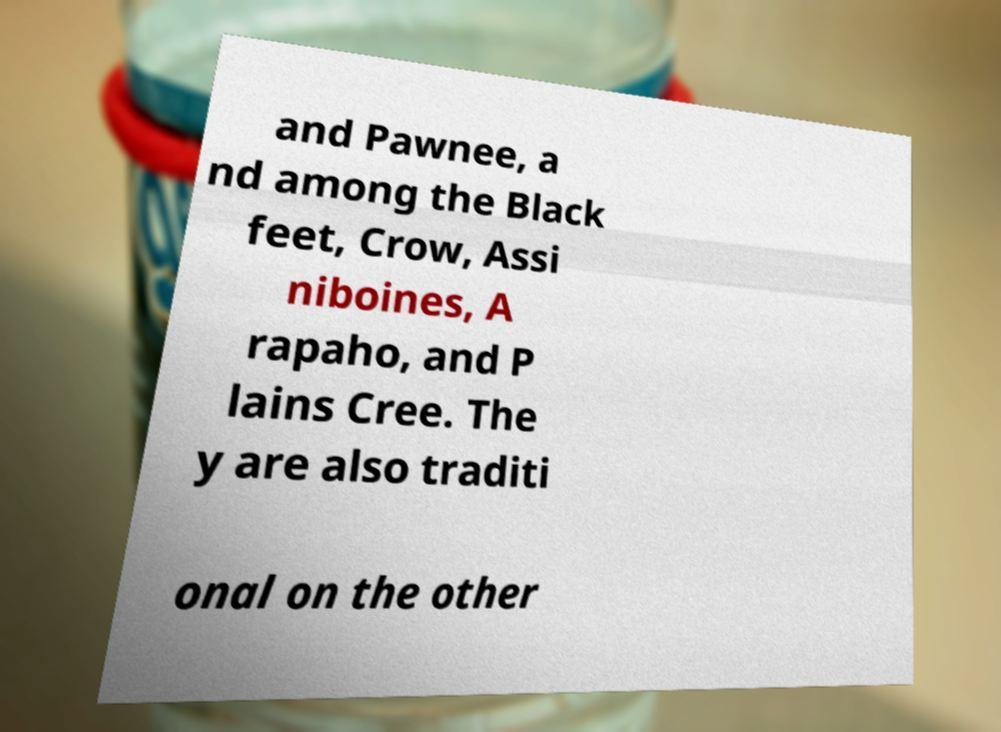I need the written content from this picture converted into text. Can you do that? and Pawnee, a nd among the Black feet, Crow, Assi niboines, A rapaho, and P lains Cree. The y are also traditi onal on the other 